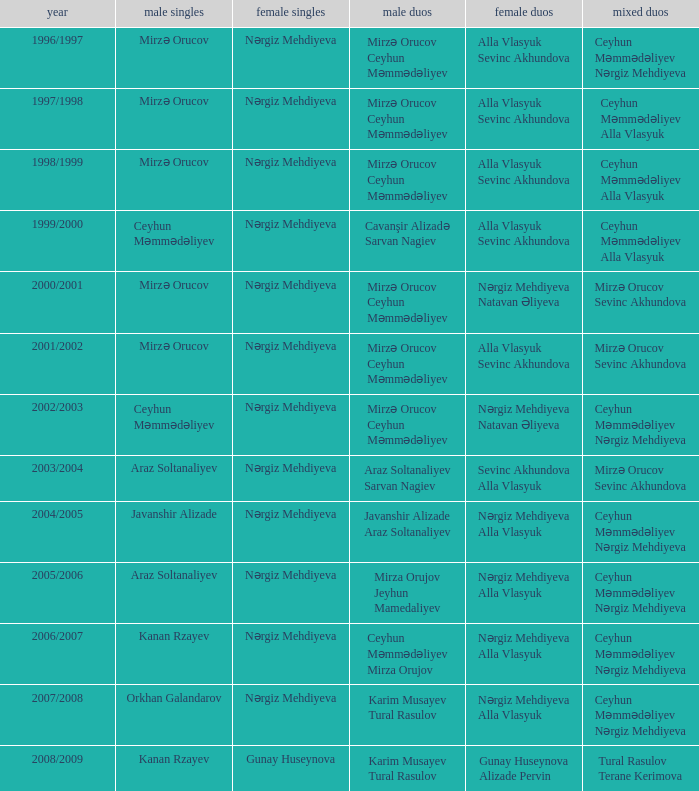Who are all the womens doubles for the year 2008/2009? Gunay Huseynova Alizade Pervin. 